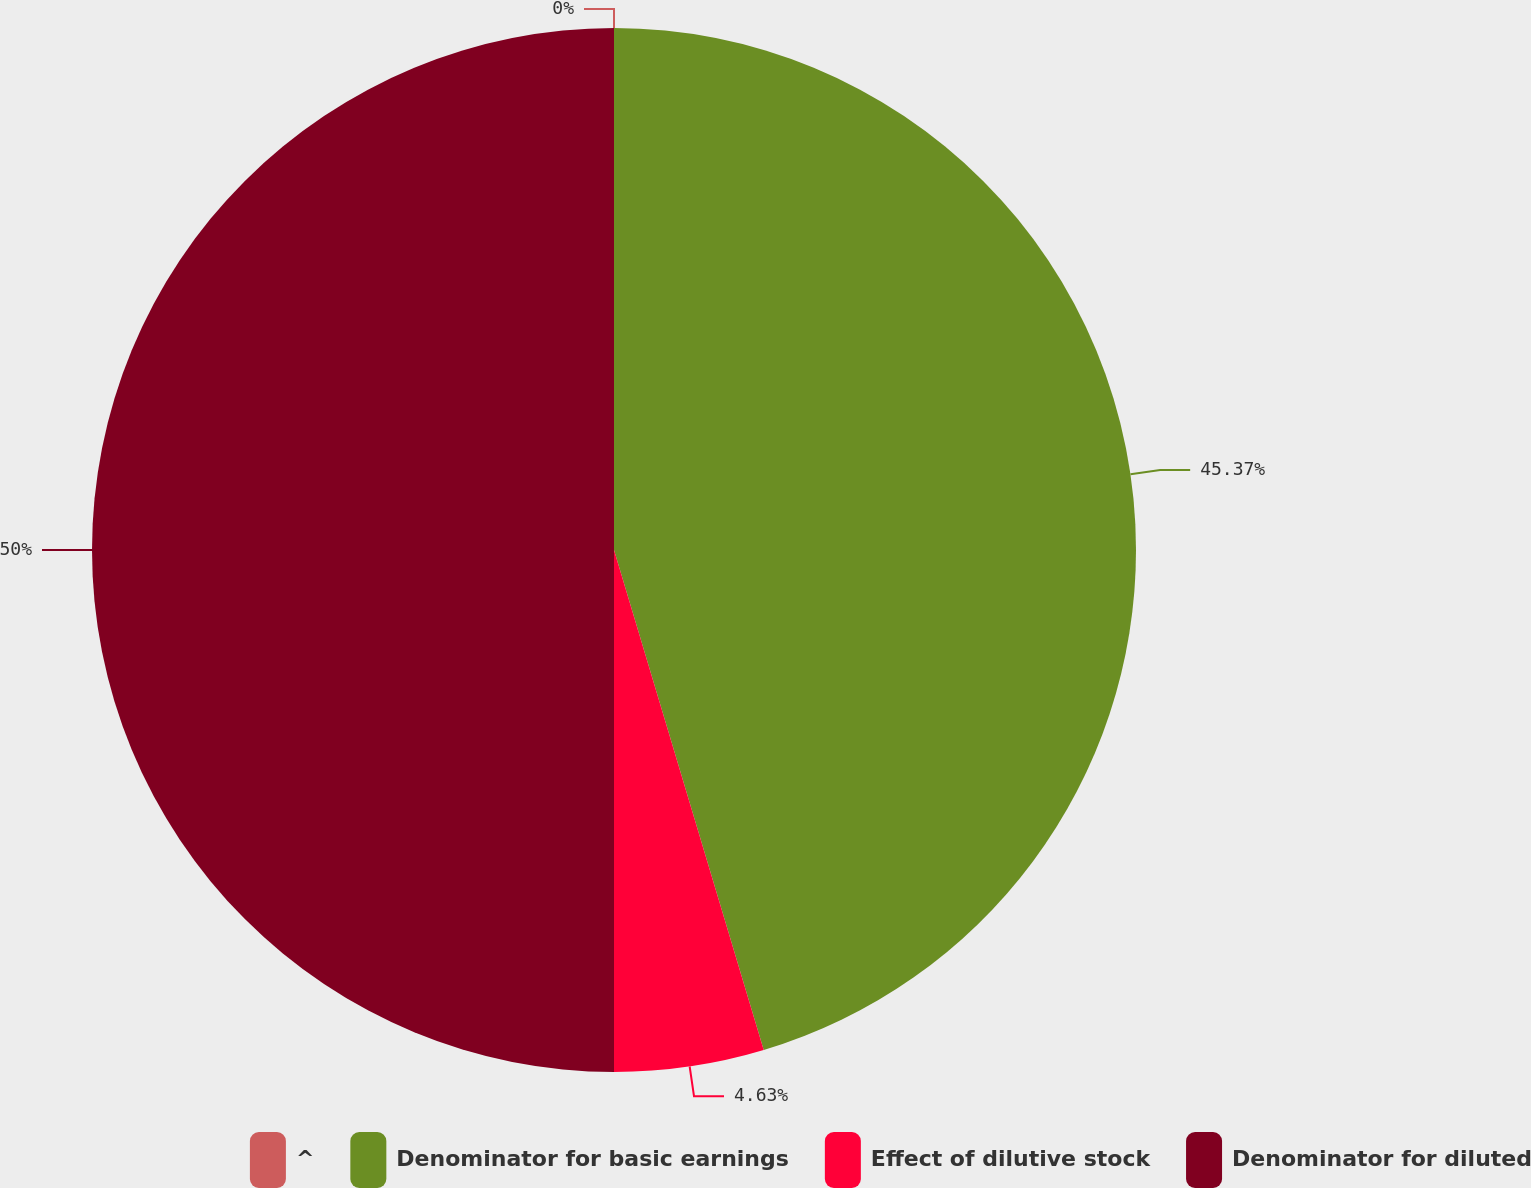Convert chart. <chart><loc_0><loc_0><loc_500><loc_500><pie_chart><fcel>^<fcel>Denominator for basic earnings<fcel>Effect of dilutive stock<fcel>Denominator for diluted<nl><fcel>0.0%<fcel>45.37%<fcel>4.63%<fcel>50.0%<nl></chart> 